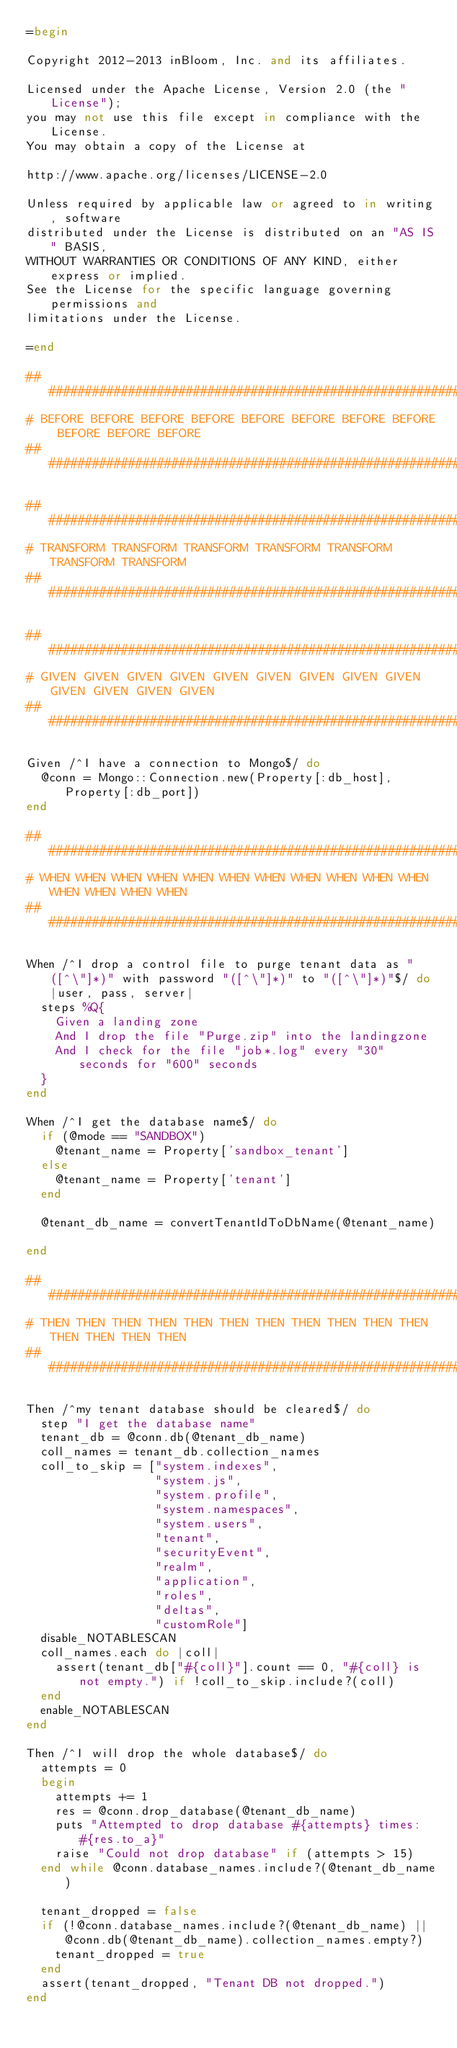Convert code to text. <code><loc_0><loc_0><loc_500><loc_500><_Ruby_>=begin

Copyright 2012-2013 inBloom, Inc. and its affiliates.

Licensed under the Apache License, Version 2.0 (the "License");
you may not use this file except in compliance with the License.
You may obtain a copy of the License at

http://www.apache.org/licenses/LICENSE-2.0

Unless required by applicable law or agreed to in writing, software
distributed under the License is distributed on an "AS IS" BASIS,
WITHOUT WARRANTIES OR CONDITIONS OF ANY KIND, either express or implied.
See the License for the specific language governing permissions and
limitations under the License.

=end

###############################################################################
# BEFORE BEFORE BEFORE BEFORE BEFORE BEFORE BEFORE BEFORE BEFORE BEFORE BEFORE
###############################################################################

###############################################################################
# TRANSFORM TRANSFORM TRANSFORM TRANSFORM TRANSFORM TRANSFORM TRANSFORM
###############################################################################

###############################################################################
# GIVEN GIVEN GIVEN GIVEN GIVEN GIVEN GIVEN GIVEN GIVEN GIVEN GIVEN GIVEN GIVEN
###############################################################################

Given /^I have a connection to Mongo$/ do
  @conn = Mongo::Connection.new(Property[:db_host], Property[:db_port])
end

###############################################################################
# WHEN WHEN WHEN WHEN WHEN WHEN WHEN WHEN WHEN WHEN WHEN WHEN WHEN WHEN WHEN
###############################################################################

When /^I drop a control file to purge tenant data as "([^\"]*)" with password "([^\"]*)" to "([^\"]*)"$/ do |user, pass, server|
  steps %Q{
    Given a landing zone
    And I drop the file "Purge.zip" into the landingzone
    And I check for the file "job*.log" every "30" seconds for "600" seconds
  }
end

When /^I get the database name$/ do
  if (@mode == "SANDBOX")
    @tenant_name = Property['sandbox_tenant']
  else
    @tenant_name = Property['tenant']
  end

  @tenant_db_name = convertTenantIdToDbName(@tenant_name)

end

###############################################################################
# THEN THEN THEN THEN THEN THEN THEN THEN THEN THEN THEN THEN THEN THEN THEN
###############################################################################

Then /^my tenant database should be cleared$/ do
  step "I get the database name"
  tenant_db = @conn.db(@tenant_db_name)
  coll_names = tenant_db.collection_names
  coll_to_skip = ["system.indexes",
                  "system.js",
                  "system.profile",
                  "system.namespaces",
                  "system.users",
                  "tenant",
                  "securityEvent",
                  "realm",
                  "application",
                  "roles",
                  "deltas",
                  "customRole"]
  disable_NOTABLESCAN
  coll_names.each do |coll|
    assert(tenant_db["#{coll}"].count == 0, "#{coll} is not empty.") if !coll_to_skip.include?(coll)
  end
  enable_NOTABLESCAN
end

Then /^I will drop the whole database$/ do
  attempts = 0
  begin
    attempts += 1
    res = @conn.drop_database(@tenant_db_name)
    puts "Attempted to drop database #{attempts} times: #{res.to_a}"
    raise "Could not drop database" if (attempts > 15)
  end while @conn.database_names.include?(@tenant_db_name)

  tenant_dropped = false
  if (!@conn.database_names.include?(@tenant_db_name) || @conn.db(@tenant_db_name).collection_names.empty?)
    tenant_dropped = true
  end
  assert(tenant_dropped, "Tenant DB not dropped.")
end
</code> 